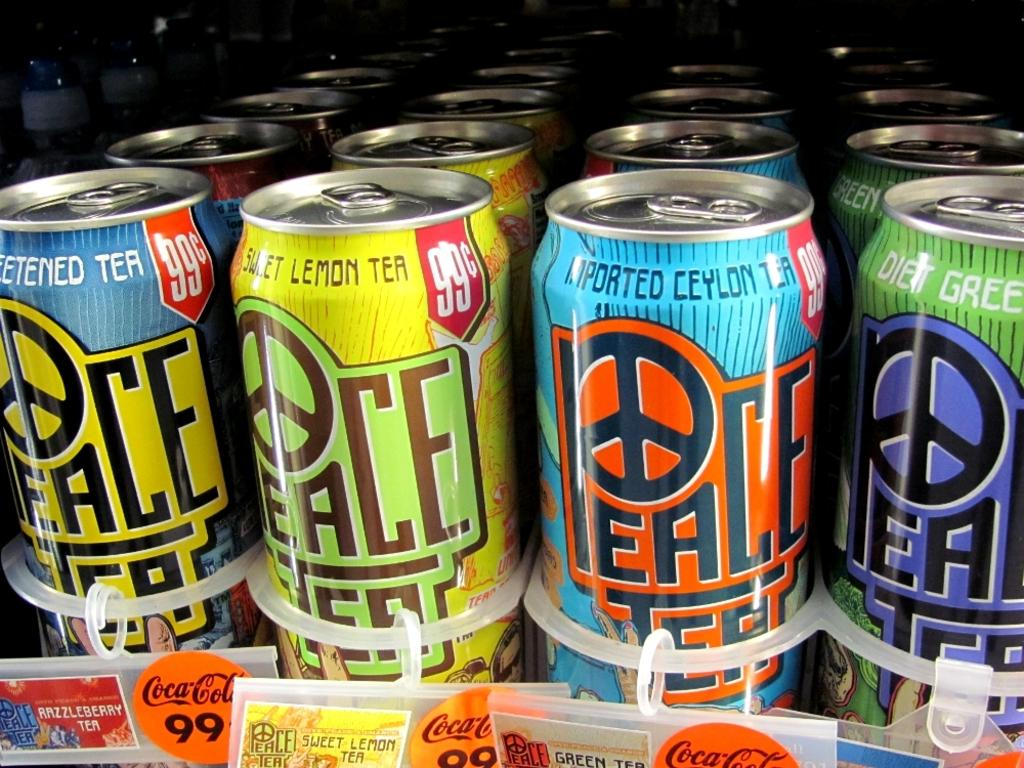<image>
Share a concise interpretation of the image provided. The inside of a store fridge that sells Peace Tea. 